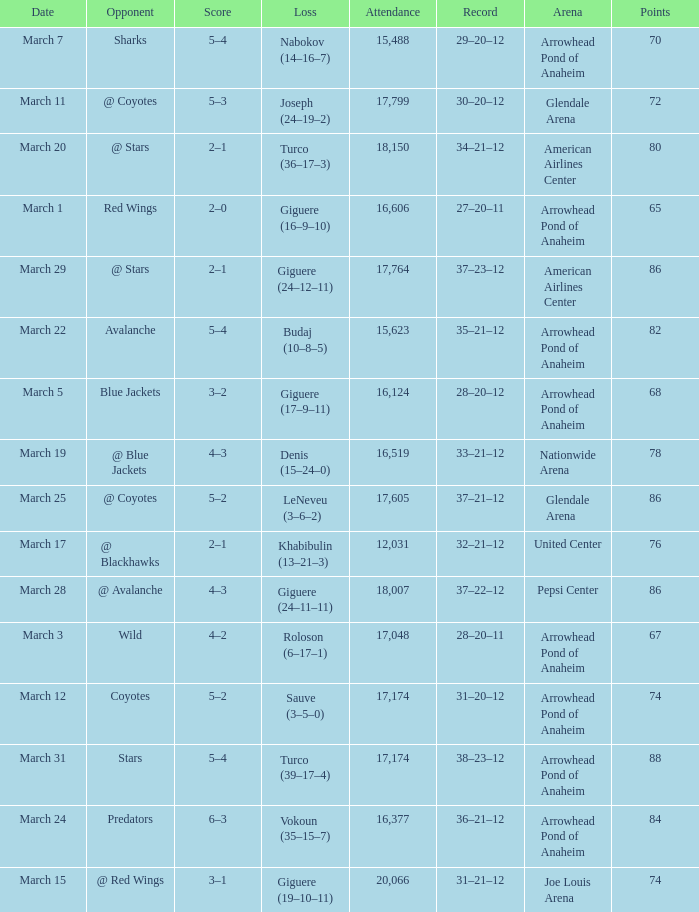What is the Attendance of the game with a Record of 37–21–12 and less than 86 Points? None. 